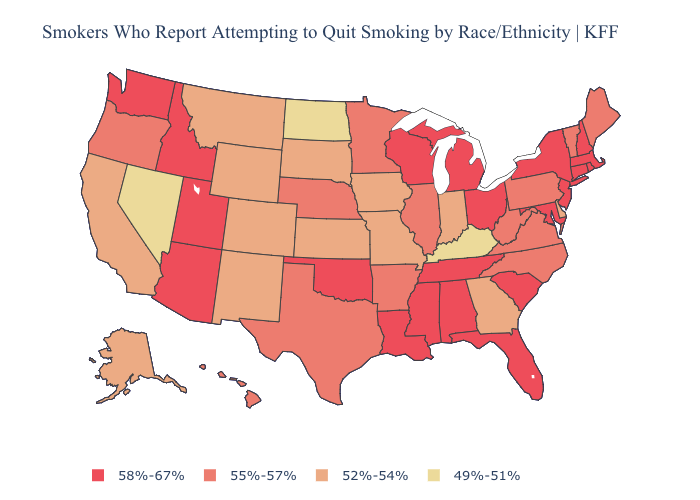Among the states that border Louisiana , which have the highest value?
Quick response, please. Mississippi. Name the states that have a value in the range 55%-57%?
Short answer required. Arkansas, Hawaii, Illinois, Maine, Minnesota, Nebraska, North Carolina, Oregon, Pennsylvania, Texas, Vermont, Virginia, West Virginia. Does Arkansas have the same value as Pennsylvania?
Quick response, please. Yes. Name the states that have a value in the range 49%-51%?
Answer briefly. Kentucky, Nevada, North Dakota. Is the legend a continuous bar?
Keep it brief. No. What is the value of Missouri?
Be succinct. 52%-54%. What is the lowest value in states that border New York?
Short answer required. 55%-57%. Which states have the lowest value in the USA?
Quick response, please. Kentucky, Nevada, North Dakota. Does the first symbol in the legend represent the smallest category?
Short answer required. No. Name the states that have a value in the range 58%-67%?
Short answer required. Alabama, Arizona, Connecticut, Florida, Idaho, Louisiana, Maryland, Massachusetts, Michigan, Mississippi, New Hampshire, New Jersey, New York, Ohio, Oklahoma, Rhode Island, South Carolina, Tennessee, Utah, Washington, Wisconsin. What is the value of New Hampshire?
Keep it brief. 58%-67%. Name the states that have a value in the range 49%-51%?
Write a very short answer. Kentucky, Nevada, North Dakota. Name the states that have a value in the range 49%-51%?
Give a very brief answer. Kentucky, Nevada, North Dakota. Among the states that border Mississippi , which have the lowest value?
Concise answer only. Arkansas. Name the states that have a value in the range 52%-54%?
Keep it brief. Alaska, California, Colorado, Delaware, Georgia, Indiana, Iowa, Kansas, Missouri, Montana, New Mexico, South Dakota, Wyoming. 